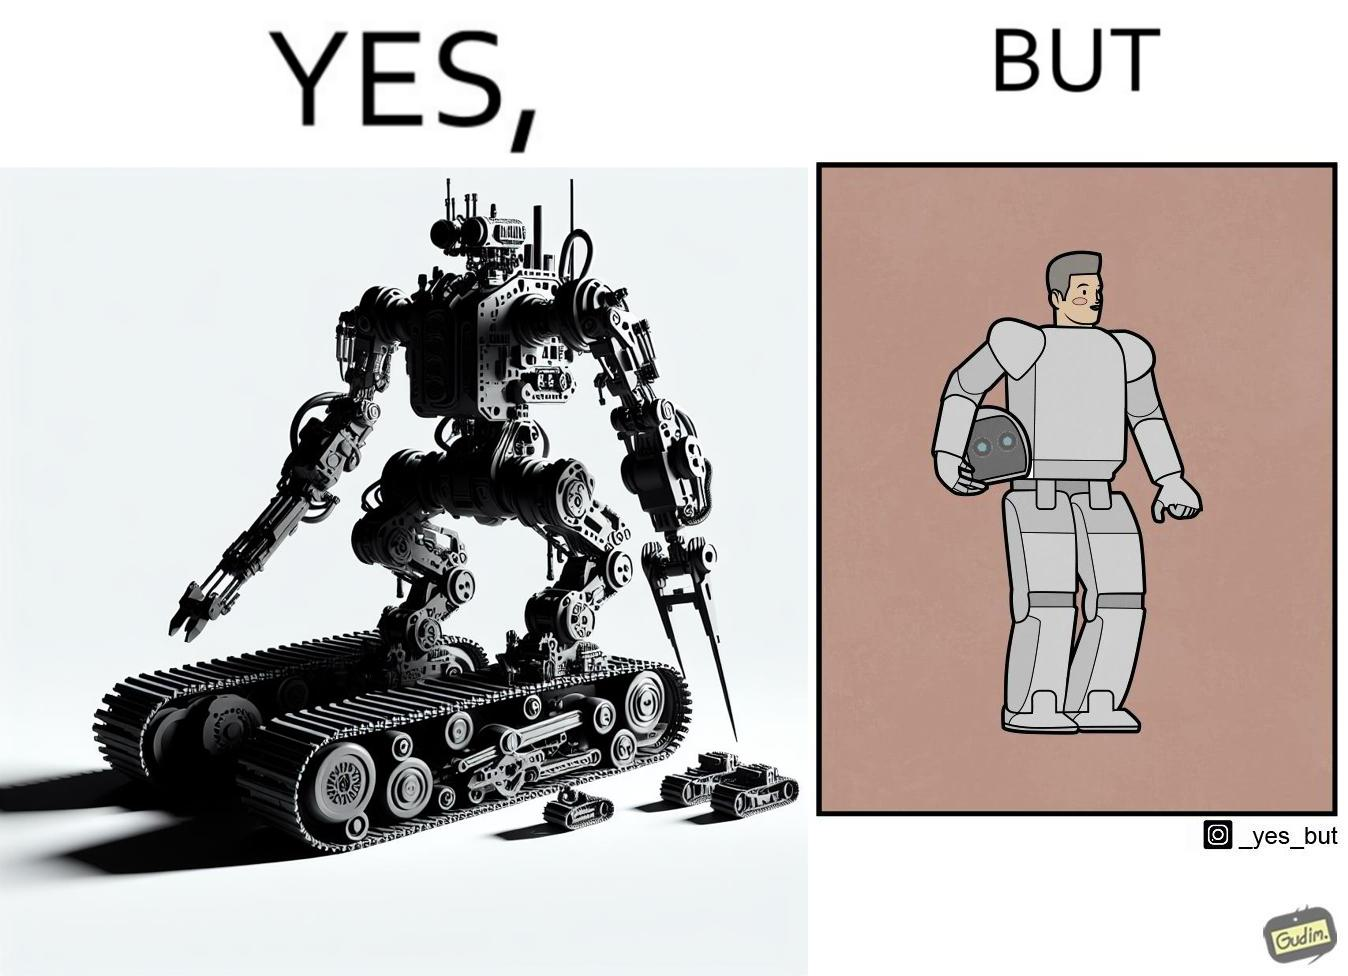Why is this image considered satirical? The images are ironic since we work to improve technology and build innovations like robots, but in the process we ourselves become less human and robotic in the way we function. 